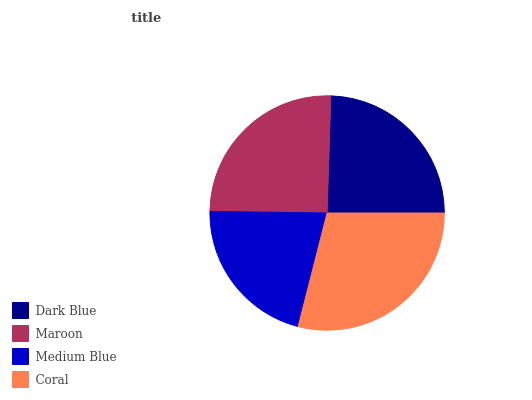Is Medium Blue the minimum?
Answer yes or no. Yes. Is Coral the maximum?
Answer yes or no. Yes. Is Maroon the minimum?
Answer yes or no. No. Is Maroon the maximum?
Answer yes or no. No. Is Maroon greater than Dark Blue?
Answer yes or no. Yes. Is Dark Blue less than Maroon?
Answer yes or no. Yes. Is Dark Blue greater than Maroon?
Answer yes or no. No. Is Maroon less than Dark Blue?
Answer yes or no. No. Is Maroon the high median?
Answer yes or no. Yes. Is Dark Blue the low median?
Answer yes or no. Yes. Is Dark Blue the high median?
Answer yes or no. No. Is Maroon the low median?
Answer yes or no. No. 